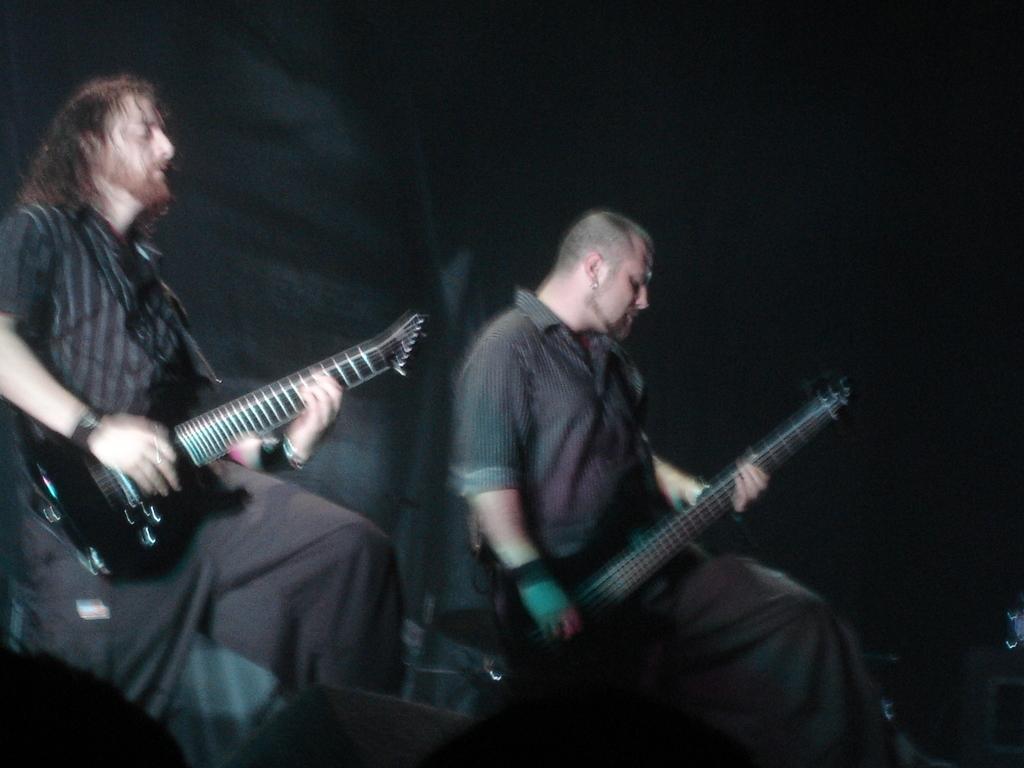Could you give a brief overview of what you see in this image? In this image there are two persons wearing black dress playing guitar. 